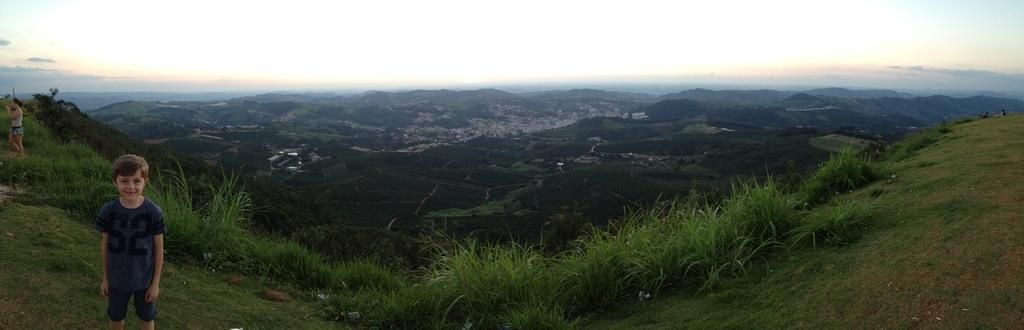Who is present in the image? There is a woman and a boy in the image. What are the woman and the boy doing? The woman and the boy are standing. What can be seen in the background of the image? There are buildings, trees, hills, and a blue and cloudy sky in the image. What is on the ground in the image? There is grass on the ground. What type of pickle is being used as a prop in the image? There is no pickle present in the image. What kind of produce is being harvested in the image? There is no produce being harvested in the image. 